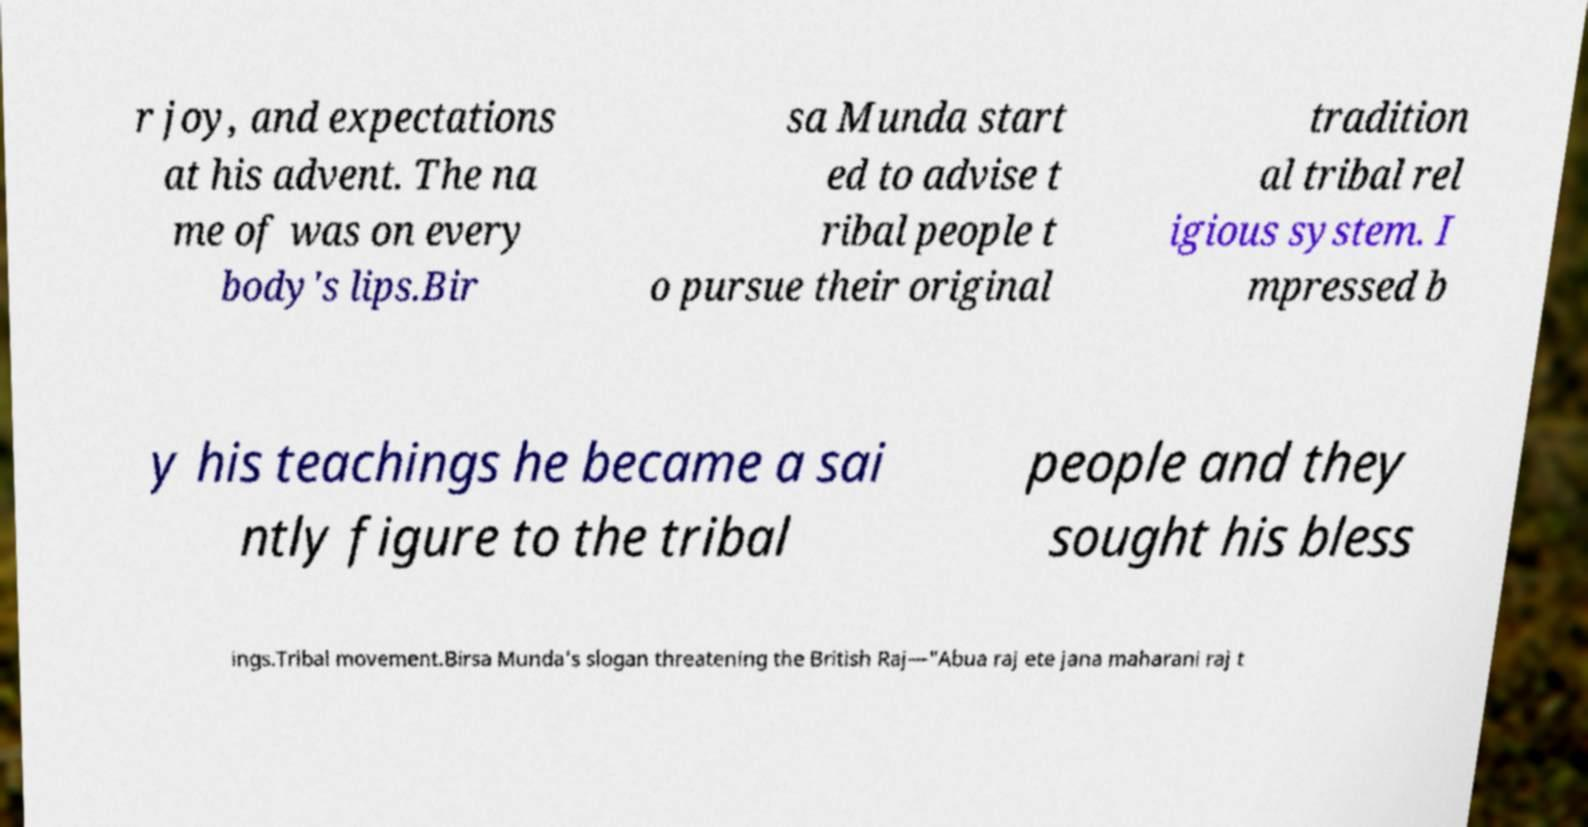Can you read and provide the text displayed in the image?This photo seems to have some interesting text. Can you extract and type it out for me? r joy, and expectations at his advent. The na me of was on every body's lips.Bir sa Munda start ed to advise t ribal people t o pursue their original tradition al tribal rel igious system. I mpressed b y his teachings he became a sai ntly figure to the tribal people and they sought his bless ings.Tribal movement.Birsa Munda's slogan threatening the British Raj—"Abua raj ete jana maharani raj t 